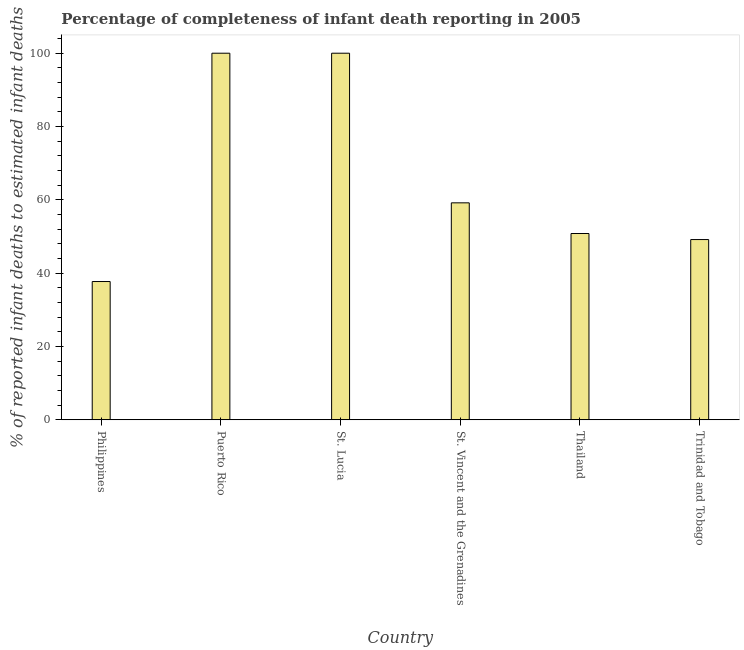Does the graph contain any zero values?
Provide a succinct answer. No. What is the title of the graph?
Provide a succinct answer. Percentage of completeness of infant death reporting in 2005. What is the label or title of the Y-axis?
Offer a very short reply. % of reported infant deaths to estimated infant deaths. What is the completeness of infant death reporting in St. Vincent and the Grenadines?
Offer a very short reply. 59.18. Across all countries, what is the maximum completeness of infant death reporting?
Give a very brief answer. 100. Across all countries, what is the minimum completeness of infant death reporting?
Your answer should be very brief. 37.72. In which country was the completeness of infant death reporting maximum?
Make the answer very short. Puerto Rico. In which country was the completeness of infant death reporting minimum?
Offer a very short reply. Philippines. What is the sum of the completeness of infant death reporting?
Provide a succinct answer. 396.89. What is the difference between the completeness of infant death reporting in St. Lucia and Trinidad and Tobago?
Offer a very short reply. 50.83. What is the average completeness of infant death reporting per country?
Offer a very short reply. 66.15. What is the median completeness of infant death reporting?
Offer a very short reply. 55. In how many countries, is the completeness of infant death reporting greater than 16 %?
Offer a very short reply. 6. What is the ratio of the completeness of infant death reporting in Puerto Rico to that in Thailand?
Provide a succinct answer. 1.97. Is the completeness of infant death reporting in St. Lucia less than that in Thailand?
Give a very brief answer. No. Is the difference between the completeness of infant death reporting in Puerto Rico and St. Vincent and the Grenadines greater than the difference between any two countries?
Keep it short and to the point. No. What is the difference between the highest and the second highest completeness of infant death reporting?
Provide a short and direct response. 0. What is the difference between the highest and the lowest completeness of infant death reporting?
Keep it short and to the point. 62.28. In how many countries, is the completeness of infant death reporting greater than the average completeness of infant death reporting taken over all countries?
Your response must be concise. 2. What is the difference between two consecutive major ticks on the Y-axis?
Your answer should be compact. 20. What is the % of reported infant deaths to estimated infant deaths of Philippines?
Your answer should be compact. 37.72. What is the % of reported infant deaths to estimated infant deaths in St. Lucia?
Offer a terse response. 100. What is the % of reported infant deaths to estimated infant deaths in St. Vincent and the Grenadines?
Your response must be concise. 59.18. What is the % of reported infant deaths to estimated infant deaths in Thailand?
Provide a succinct answer. 50.82. What is the % of reported infant deaths to estimated infant deaths of Trinidad and Tobago?
Make the answer very short. 49.17. What is the difference between the % of reported infant deaths to estimated infant deaths in Philippines and Puerto Rico?
Ensure brevity in your answer.  -62.28. What is the difference between the % of reported infant deaths to estimated infant deaths in Philippines and St. Lucia?
Your answer should be compact. -62.28. What is the difference between the % of reported infant deaths to estimated infant deaths in Philippines and St. Vincent and the Grenadines?
Your response must be concise. -21.46. What is the difference between the % of reported infant deaths to estimated infant deaths in Philippines and Thailand?
Your response must be concise. -13.1. What is the difference between the % of reported infant deaths to estimated infant deaths in Philippines and Trinidad and Tobago?
Offer a terse response. -11.45. What is the difference between the % of reported infant deaths to estimated infant deaths in Puerto Rico and St. Lucia?
Offer a very short reply. 0. What is the difference between the % of reported infant deaths to estimated infant deaths in Puerto Rico and St. Vincent and the Grenadines?
Provide a short and direct response. 40.82. What is the difference between the % of reported infant deaths to estimated infant deaths in Puerto Rico and Thailand?
Offer a very short reply. 49.18. What is the difference between the % of reported infant deaths to estimated infant deaths in Puerto Rico and Trinidad and Tobago?
Keep it short and to the point. 50.83. What is the difference between the % of reported infant deaths to estimated infant deaths in St. Lucia and St. Vincent and the Grenadines?
Offer a very short reply. 40.82. What is the difference between the % of reported infant deaths to estimated infant deaths in St. Lucia and Thailand?
Offer a terse response. 49.18. What is the difference between the % of reported infant deaths to estimated infant deaths in St. Lucia and Trinidad and Tobago?
Your answer should be compact. 50.83. What is the difference between the % of reported infant deaths to estimated infant deaths in St. Vincent and the Grenadines and Thailand?
Offer a terse response. 8.37. What is the difference between the % of reported infant deaths to estimated infant deaths in St. Vincent and the Grenadines and Trinidad and Tobago?
Offer a terse response. 10.02. What is the difference between the % of reported infant deaths to estimated infant deaths in Thailand and Trinidad and Tobago?
Ensure brevity in your answer.  1.65. What is the ratio of the % of reported infant deaths to estimated infant deaths in Philippines to that in Puerto Rico?
Your answer should be compact. 0.38. What is the ratio of the % of reported infant deaths to estimated infant deaths in Philippines to that in St. Lucia?
Offer a terse response. 0.38. What is the ratio of the % of reported infant deaths to estimated infant deaths in Philippines to that in St. Vincent and the Grenadines?
Offer a terse response. 0.64. What is the ratio of the % of reported infant deaths to estimated infant deaths in Philippines to that in Thailand?
Give a very brief answer. 0.74. What is the ratio of the % of reported infant deaths to estimated infant deaths in Philippines to that in Trinidad and Tobago?
Your response must be concise. 0.77. What is the ratio of the % of reported infant deaths to estimated infant deaths in Puerto Rico to that in St. Lucia?
Ensure brevity in your answer.  1. What is the ratio of the % of reported infant deaths to estimated infant deaths in Puerto Rico to that in St. Vincent and the Grenadines?
Your answer should be compact. 1.69. What is the ratio of the % of reported infant deaths to estimated infant deaths in Puerto Rico to that in Thailand?
Keep it short and to the point. 1.97. What is the ratio of the % of reported infant deaths to estimated infant deaths in Puerto Rico to that in Trinidad and Tobago?
Your answer should be compact. 2.03. What is the ratio of the % of reported infant deaths to estimated infant deaths in St. Lucia to that in St. Vincent and the Grenadines?
Offer a terse response. 1.69. What is the ratio of the % of reported infant deaths to estimated infant deaths in St. Lucia to that in Thailand?
Ensure brevity in your answer.  1.97. What is the ratio of the % of reported infant deaths to estimated infant deaths in St. Lucia to that in Trinidad and Tobago?
Your answer should be compact. 2.03. What is the ratio of the % of reported infant deaths to estimated infant deaths in St. Vincent and the Grenadines to that in Thailand?
Keep it short and to the point. 1.17. What is the ratio of the % of reported infant deaths to estimated infant deaths in St. Vincent and the Grenadines to that in Trinidad and Tobago?
Provide a short and direct response. 1.2. What is the ratio of the % of reported infant deaths to estimated infant deaths in Thailand to that in Trinidad and Tobago?
Ensure brevity in your answer.  1.03. 